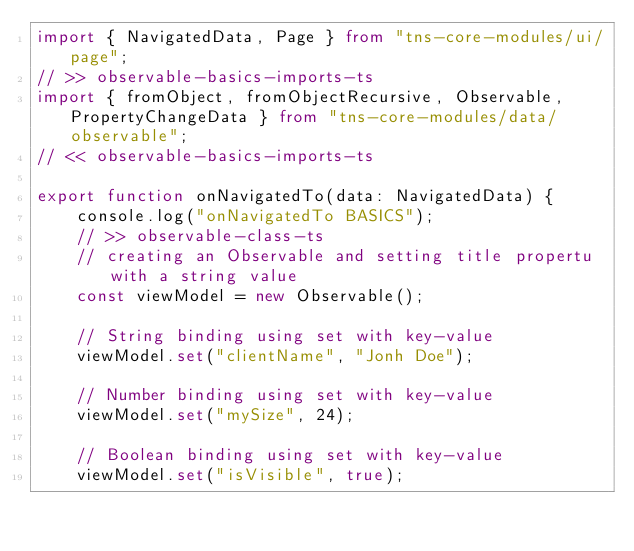<code> <loc_0><loc_0><loc_500><loc_500><_TypeScript_>import { NavigatedData, Page } from "tns-core-modules/ui/page";
// >> observable-basics-imports-ts
import { fromObject, fromObjectRecursive, Observable, PropertyChangeData } from "tns-core-modules/data/observable";
// << observable-basics-imports-ts

export function onNavigatedTo(data: NavigatedData) {
    console.log("onNavigatedTo BASICS");
    // >> observable-class-ts
    // creating an Observable and setting title propertu with a string value
    const viewModel = new Observable();

    // String binding using set with key-value
    viewModel.set("clientName", "Jonh Doe");

    // Number binding using set with key-value
    viewModel.set("mySize", 24);

    // Boolean binding using set with key-value
    viewModel.set("isVisible", true);
</code> 